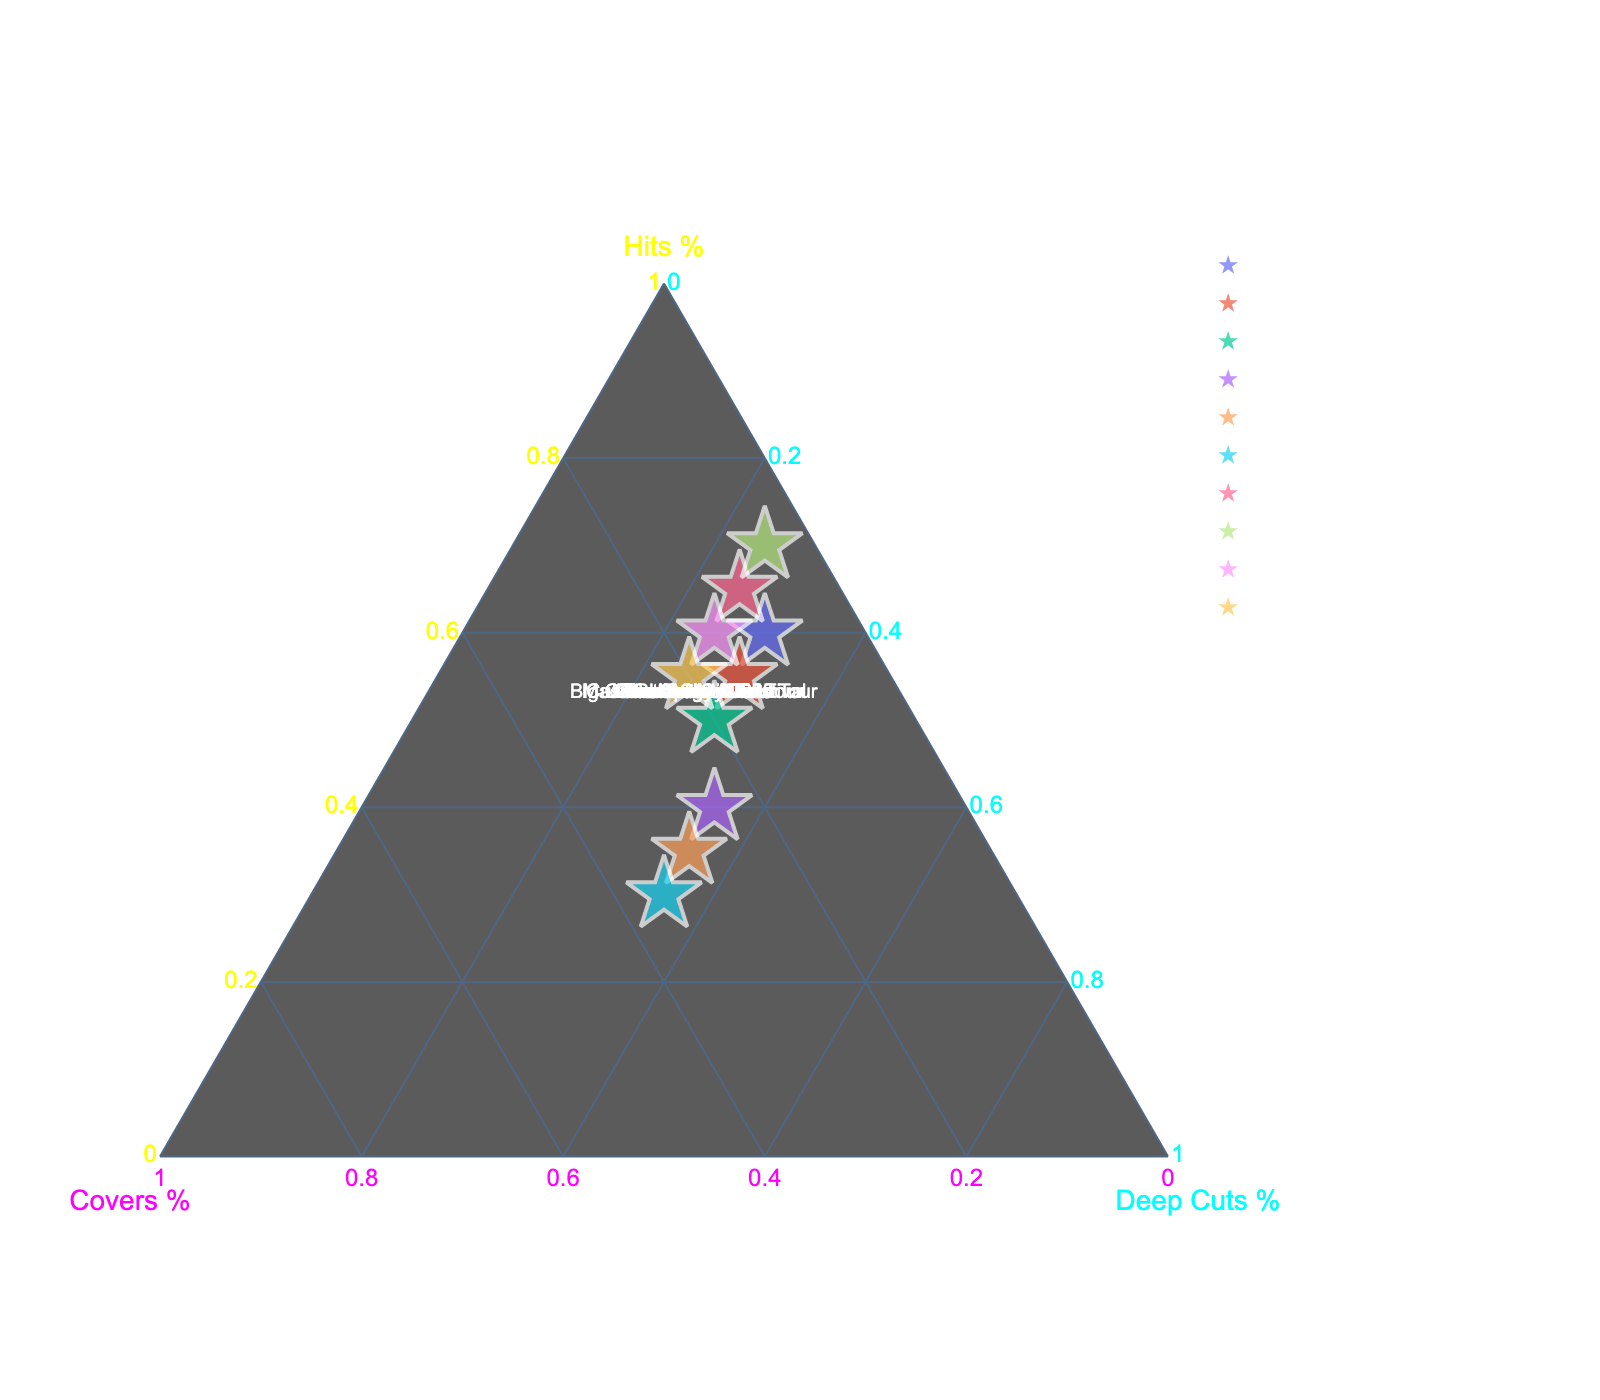What's the title of the figure? The title is usually located at the top of the figure. It provides a summary of what the plot represents.
Answer: "Lizzo's Concert Setlist Composition" What are the three axes labeled in the ternary plot? Ternary plots have three axes, each representing a component in a combination. The labels show what each axis denotes.
Answer: Hits %, Covers %, Deep Cuts % How many concerts are represented in the plot? Count the number of data points or labels representing different concerts. Each point corresponds to a concert setlist.
Answer: 10 Which concert had the highest percentage of hits? Locate the data point that is farthest along the Hits % axis. This point will represent the concert with the highest percentage of hits.
Answer: "Glastonbury 2023" Which concert had an equal percentage of covers and deep cuts? Look for a data point that lies along the line where covers and deep cuts percentages are equal.
Answer: "Coconut Oil Tour" and "Big GRRL Small World Tour" What is the range of the percentage of deep cuts across the concerts? Identify the minimum and maximum values on the Deep Cuts % axis to determine the range.
Answer: 25% to 35% Which two concerts have the closest setlist composition? Compare the positions of data points to find the two closest points, indicating similar setlist compositions.
Answer: "Made in America Festival" and "Austin City Limits" On average, which type of song dominates Lizzo's setlists across all concerts? Calculate the average percentage for hits, covers, and deep cuts across all concerts and compare them.
Answer: Hits dominate What's the combined percentage of covers and deep cuts for "Cuz I Love You Too Tour"? Sum the covers and deep cuts percentages for this tour to find the combined share.
Answer: 45% Which concert features the least amount of covers? Find the data point nearest to the Hits-Deep Cuts axis, indicating the smallest percentage of covers.
Answer: "Glastonbury 2023" 